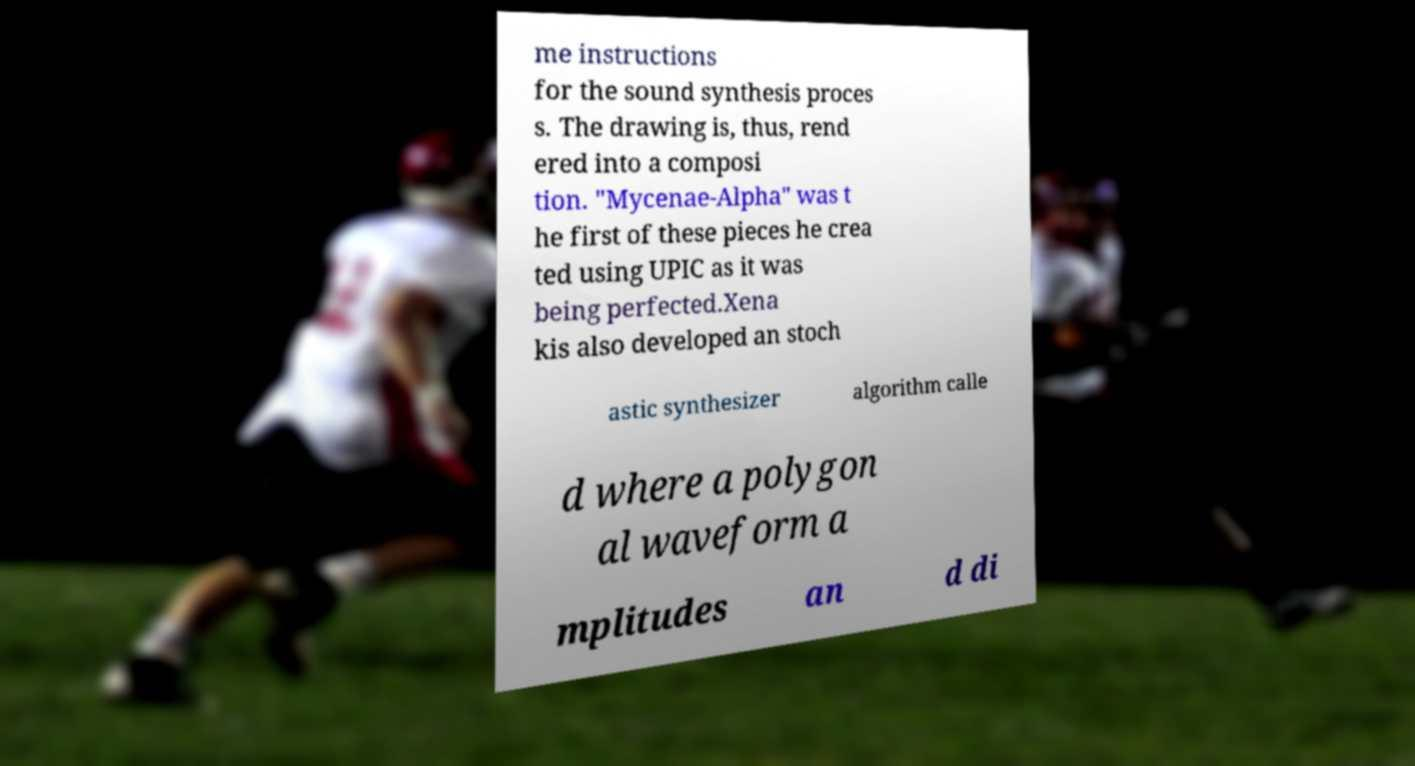There's text embedded in this image that I need extracted. Can you transcribe it verbatim? me instructions for the sound synthesis proces s. The drawing is, thus, rend ered into a composi tion. "Mycenae-Alpha" was t he first of these pieces he crea ted using UPIC as it was being perfected.Xena kis also developed an stoch astic synthesizer algorithm calle d where a polygon al waveform a mplitudes an d di 